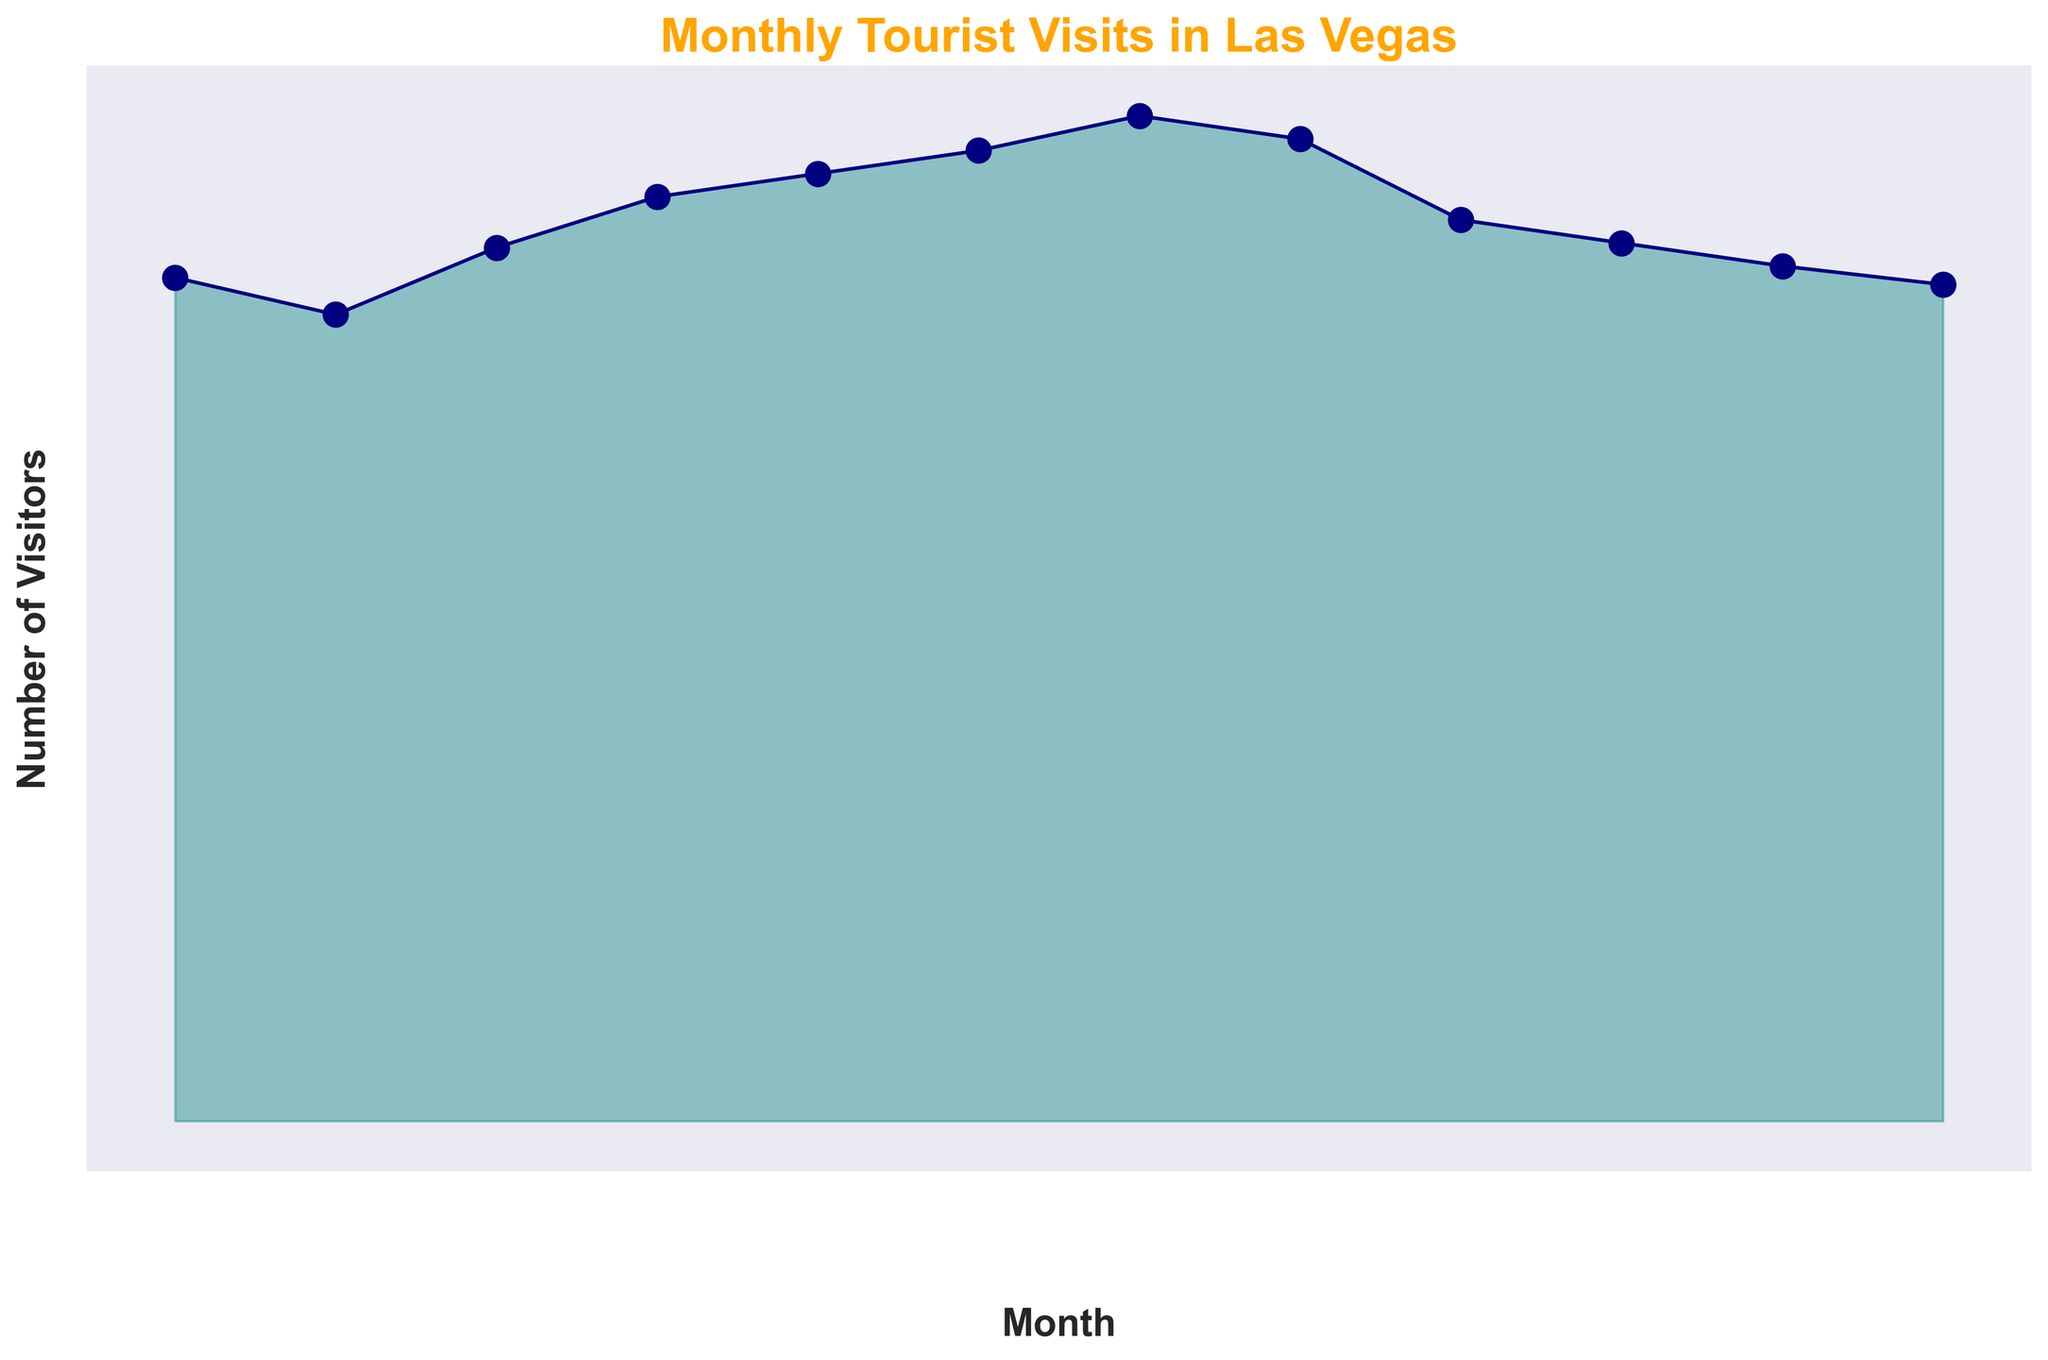How many visitors did Las Vegas receive in total during the summer months (June, July, and August)? To find the total visitors during the summer months, sum the number of visitors for June, July, and August. The visitors for June are 4,200,000, for July are 4,350,000, and for August are 4,250,000. Therefore, the total is 4,200,000 + 4,350,000 + 4,250,000 = 12,800,000.
Answer: 12,800,000 Which month had the highest number of tourist visits? By observing the height of the area chart, we can see that July has the highest peak, indicating it had the maximum number of visitors. The number of tourists in July is 4,350,000.
Answer: July During which month was the number of visitors closest to 4,000,000? Referring to the vertical height and numeric labels, April had 4,000,000 visitors, which is exactly 4,000,000.
Answer: April By how much did the number of tourists decrease from July to September? First, note the number of visitors in July (4,350,000) and September (3,900,000). Subtract the number of visitors in September from those in July: 4,350,000 - 3,900,000 = 450,000. Hence, the decrease is 450,000 visitors.
Answer: 450,000 Which month had the closest number of visitors to February? Referring to the chart, February had 3,490,000 visitors. November, with 3,700,000 visitors, is closest to this number when comparing heights of the corresponding areas.
Answer: November What is the average number of visitors per month based on the chart? To find the average number of visitors per month, sum all visitors and divide by 12 (the number of months). The total visitors over the year is 44,630,000. Divide this by 12: 44,630,000 / 12 = 3,719,167 (approximately).
Answer: 3,719,167 Did Las Vegas have more tourists in the first half or the second half of the year? First, calculate the total visitors for January to June and July to December. Sum for January-June: 3,650,000 + 3,490,000 + 3,780,000 + 4,000,000 + 4,100,000 + 4,200,000 = 23,220,000. Sum for July-December: 4,350,000 + 4,250,000 + 3,900,000 + 3,800,000 + 3,700,000 + 3,620,000 = 23,620,000. The second half has more tourists.
Answer: Second half How does the number of visitors in March compare to the number of visitors in October? Referring to the chart, March had 3,780,000 visitors and October had 3,800,000 visitors. October had slightly more visitors by 20,000.
Answer: October What is the difference in the number of visitors between the busiest and least busy months? The busiest month is July (4,350,000 visitors) and the least busy is February (3,490,000 visitors). The difference is 4,350,000 - 3,490,000 = 860,000 visitors.
Answer: 860,000 How many months had at least 4,000,000 visitors? By scanning the chart, the months with at least 4,000,000 visitors are April, May, June, July, and August. Counting these months, we get 5 months.
Answer: 5 